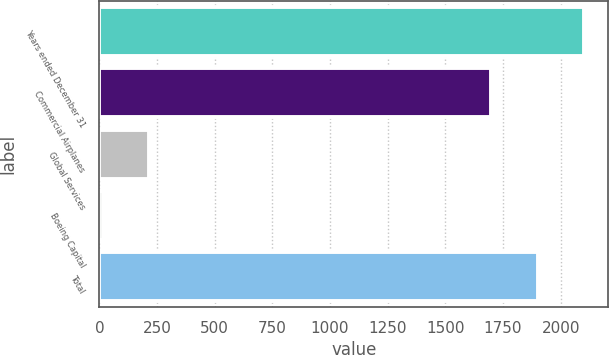Convert chart to OTSL. <chart><loc_0><loc_0><loc_500><loc_500><bar_chart><fcel>Years ended December 31<fcel>Commercial Airplanes<fcel>Global Services<fcel>Boeing Capital<fcel>Total<nl><fcel>2100<fcel>1700<fcel>215<fcel>15<fcel>1900<nl></chart> 